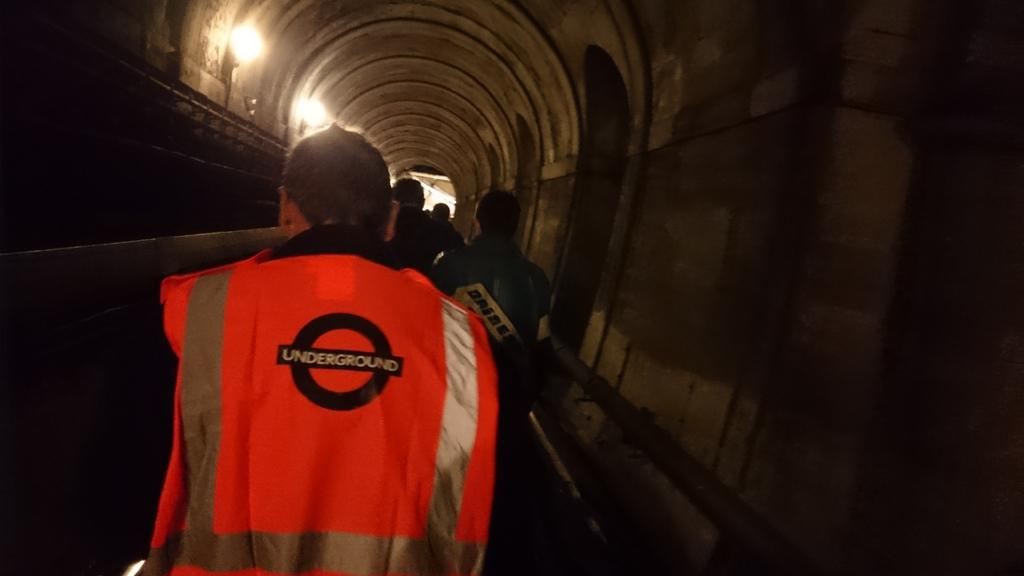<image>
Create a compact narrative representing the image presented. A man in a tunnel wearing an orange Underground vest. 